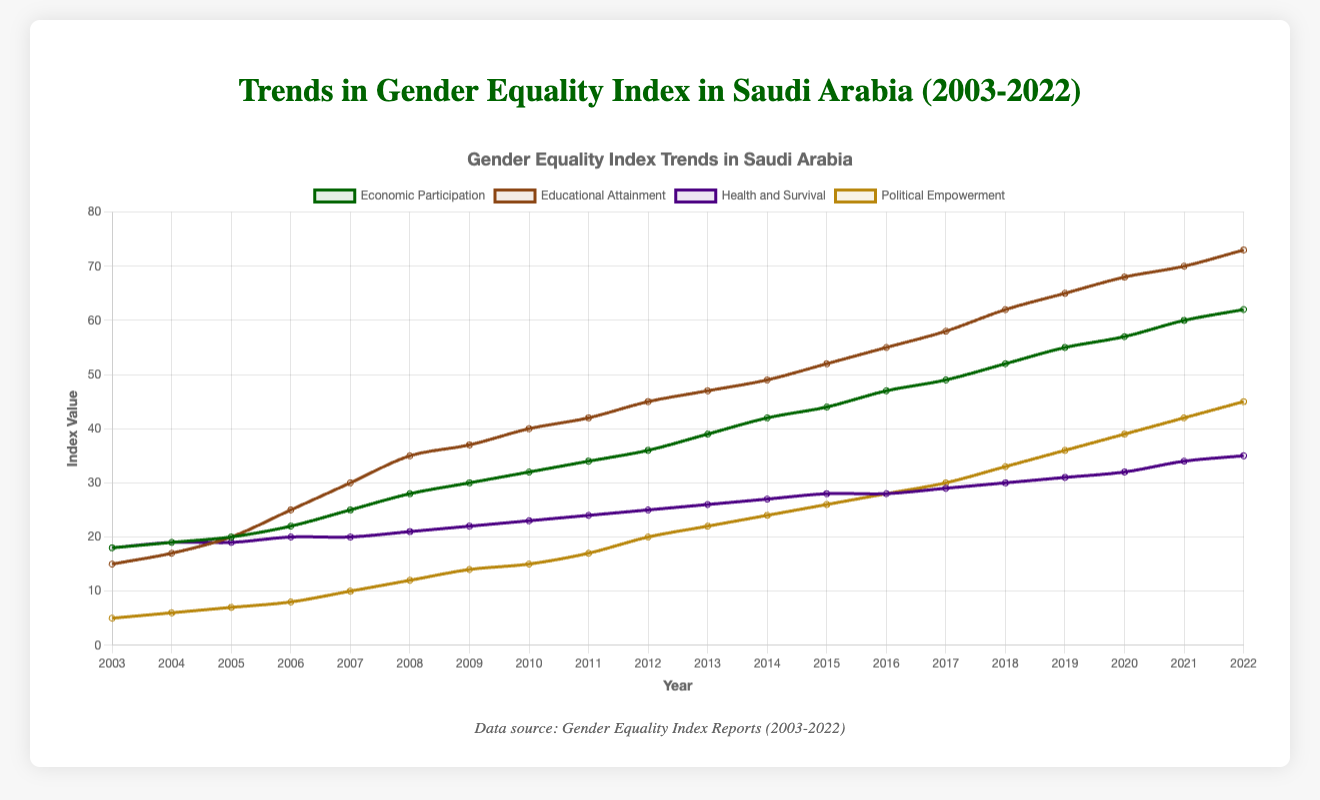What year saw the biggest increase in the "Educational Attainment" index? By comparing the yearly increments for the "Educational Attainment" index, the biggest increase occurred between 2008 and 2009, where it increased from 35 to 37, a jump of 2 points.
Answer: 2008-2009 Which category had the highest index value in 2022? In 2022, the highest category values were: Economic Participation (62), Educational Attainment (73), Health and Survival (35), Political Empowerment (45). The highest index value is thus "Educational Attainment" with a value of 73.
Answer: Educational Attainment How much did the "Economic Participation" index increase from 2003 to 2022? The index for Economic Participation in 2003 was 18, and in 2022 it was 62. The increase is calculated as 62 - 18 = 44.
Answer: 44 In which year did "Health and Survival" see its first increase since 2003? Examining the "Health and Survival" figures, we see that it first increased from 18 in 2003 to 19 in 2004.
Answer: 2004 In which two adjacent years did "Political Empowerment" have the smallest increase? By comparing the year-to-year increments in "Political Empowerment," the smallest increase was between 2016 and 2017, with a rise from 28 to 30, an increment of 2 points.
Answer: 2016-2017 Which index in 2007 was closest to 50% of its value in 2022? To determine this, calculate 50% of the 2022 values and compare: Economic Participation (62/2 = 31), Educational Attainment (73/2 = 36.5), Health and Survival (35/2 = 17.5), and Political Empowerment (45/2 = 22.5). "Economic Participation" in 2007 (25) is closest to 31.
Answer: Economic Participation Which index had the most consistent yearly growth? Evaluating the trend lines of each index, "Educational Attainment" shows consistent increase over the years, with steady increments each year without significant dips.
Answer: Educational Attainment What was the average increase per year of the "Political Empowerment" index from 2003 to 2022? "Political Empowerment" increased from 5 in 2003 to 45 in 2022. Over 19 years, the total increase was 40. The average annual increase is 40/19 ≈ 2.11.
Answer: 2.11 